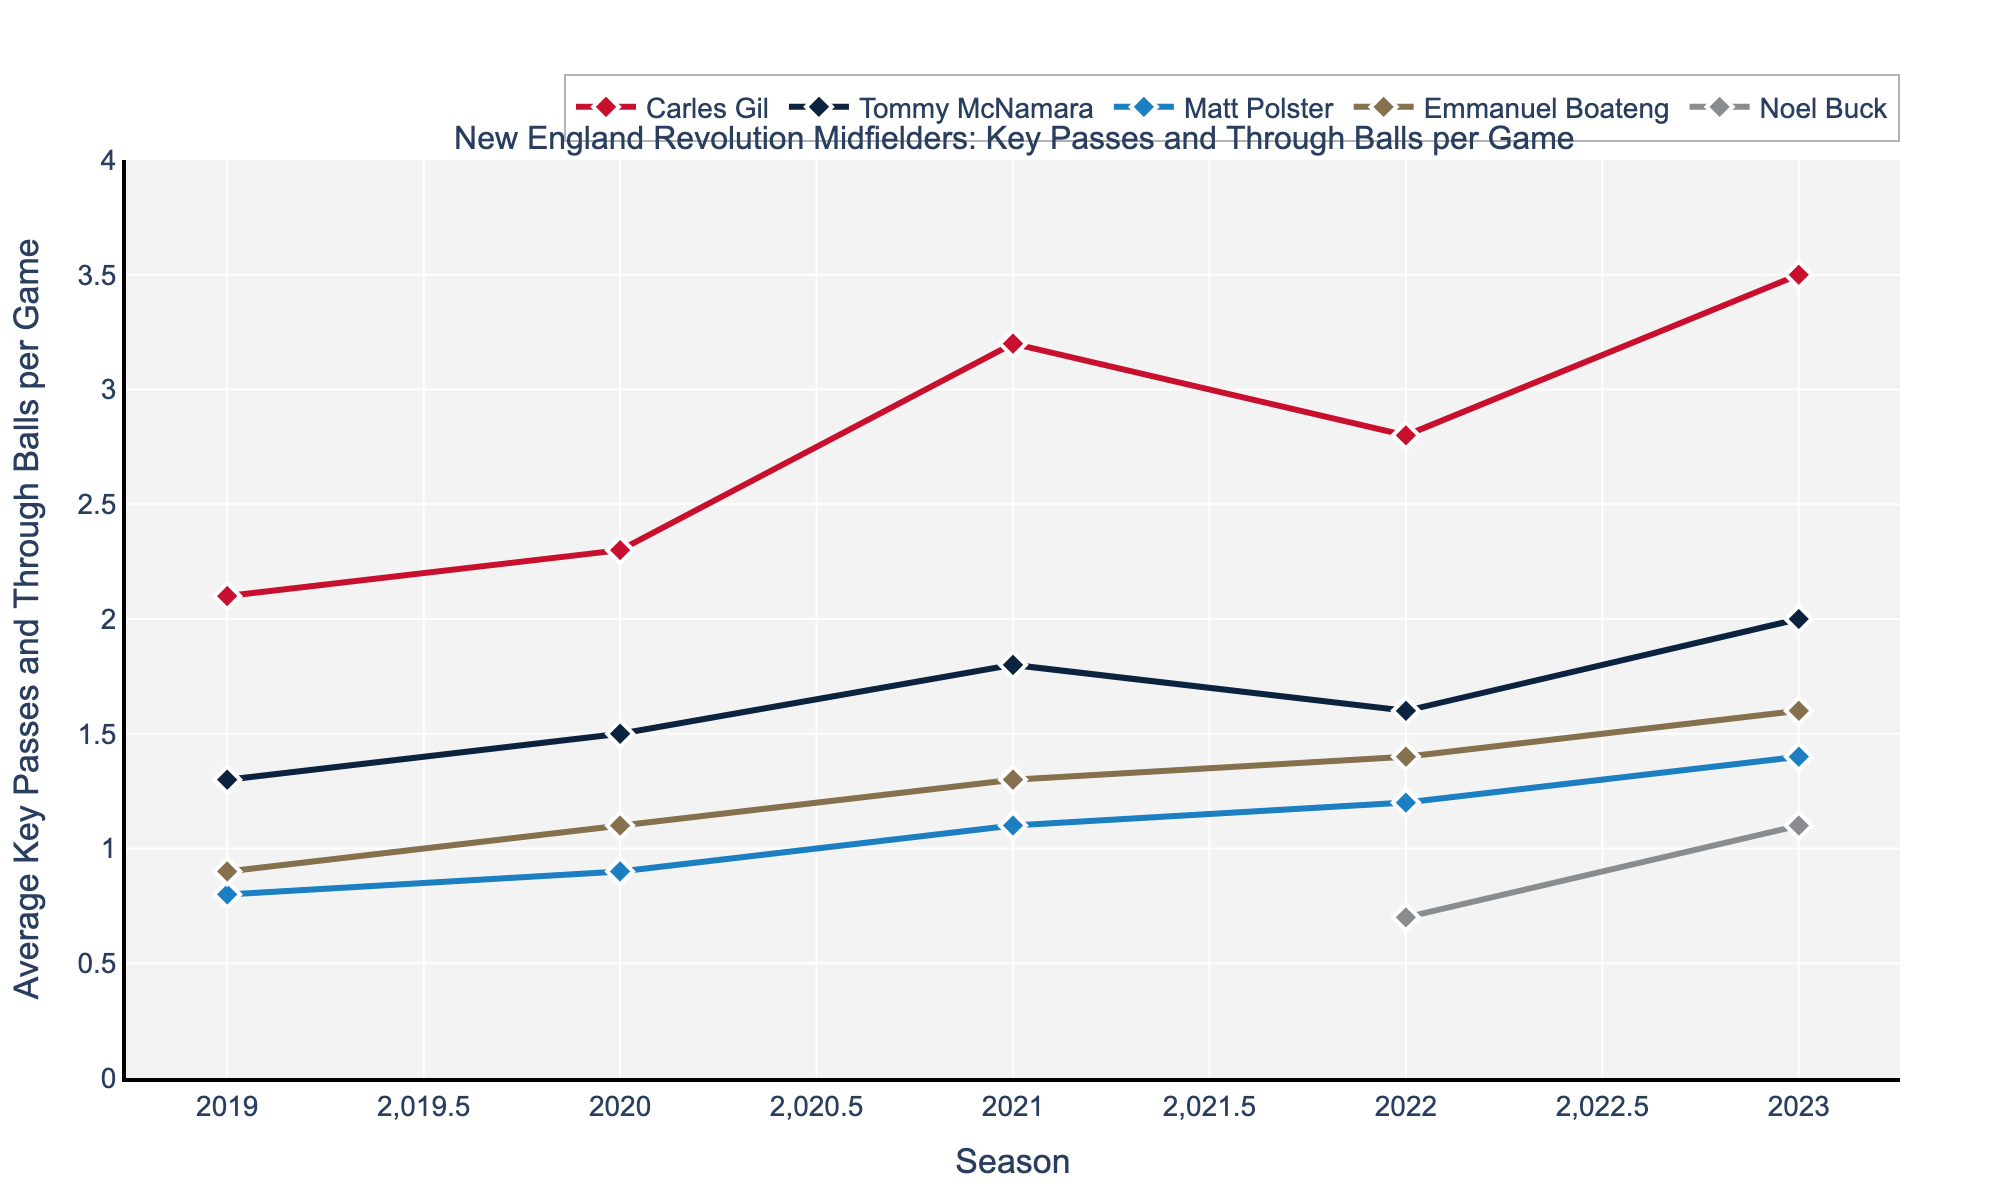what is the trend in Carles Gil's average number of key passes and through balls per game from 2019 to 2023? To answer this, observe Carles Gil's line on the plot. In 2019, it starts at 2.1; then increases to 2.3 in 2020. It peaks at 3.2 in 2021, dips slightly to 2.8 in 2022, and rises again to 3.5 in 2023. This indicates an overall increasing trend with some fluctuations.
Answer: Increasing trend Which player had the highest average number of key passes and through balls per game in 2021? Focus on the lines and markers for the year 2021. Carles Gil's mark in 2021 is at 3.2, which is the highest compared to others (Tommy McNamara at 1.8, Matt Polster at 1.1, Emmanuel Boateng at 1.3).
Answer: Carles Gil How did Noel Buck's average number of key passes and through balls per game change from 2022 to 2023? Referring to Noel Buck's data points, he starts with 0.7 in 2022 and increases to 1.1 in 2023. This indicates an increase.
Answer: Increase What was the combined average number of key passes and through balls per game for Tommy McNamara and Matt Polster in 2020? First, locate Tommy McNamara's and Matt Polster's values for 2020, which are 1.5 and 0.9 respectively. The combined average is 1.5 + 0.9 = 2.4.
Answer: 2.4 Which player showed the most significant improvement in key passes and through balls per game from 2019 to 2023? Compare each player's starting and ending values: Carles Gil (2.1 to 3.5 = +1.4), Tommy McNamara (1.3 to 2.0 = +0.7), Matt Polster (0.8 to 1.4 = +0.6), Emmanuel Boateng (0.9 to 1.6 = +0.7). Carles Gil had the largest increase (+1.4).
Answer: Carles Gil Did any player have a decrease in their average number of key passes and through balls per game between any consecutive years? Checking each player's trend, Carles Gil decreased from 3.2 in 2021 to 2.8 in 2022. No significant decreases for others in consecutive years.
Answer: Carles Gil Which player's line is represented in red? According to the given custom color palette, the first player's line is red. Hence, Carles Gil's line is represented in red.
Answer: Carles Gil Whats the difference in average number of key passes and through balls per game between Emmanuel Boateng and Noel Buck in 2023? Emmanuel Boateng has a value of 1.6 and Noel Buck has 1.1 in 2023. The difference is 1.6 - 1.1 = 0.5.
Answer: 0.5 